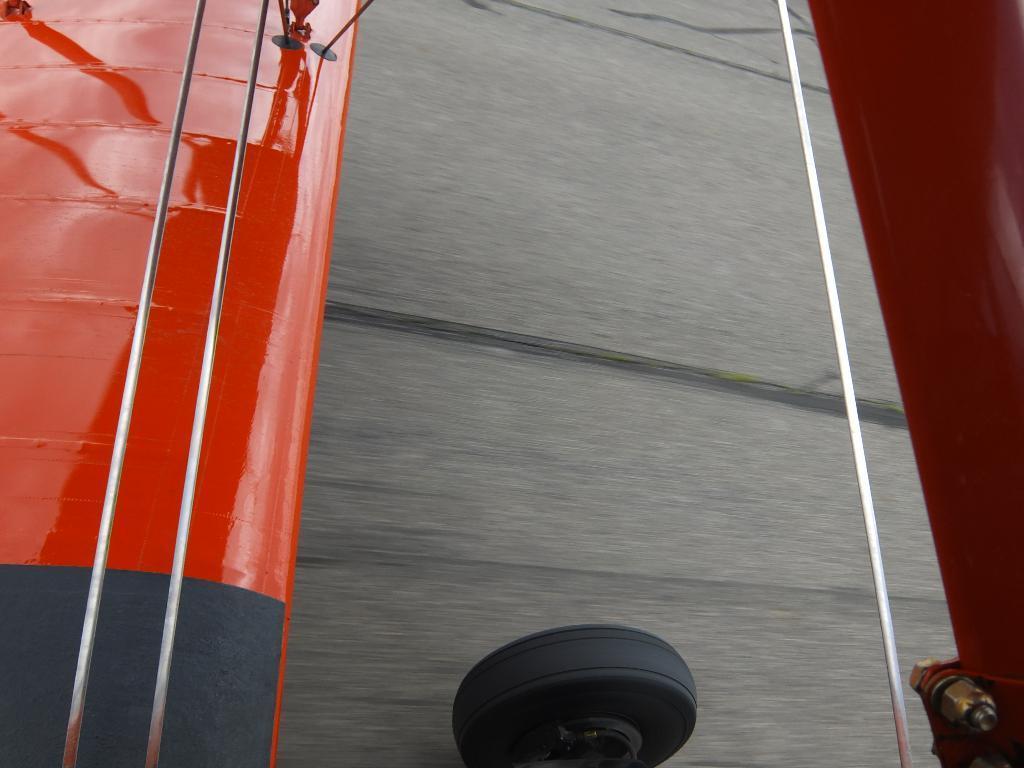How would you summarize this image in a sentence or two? At the bottom of the image we can see a tire and on its sides there are some rods and red colored objects, which looks like an airplane wing. 